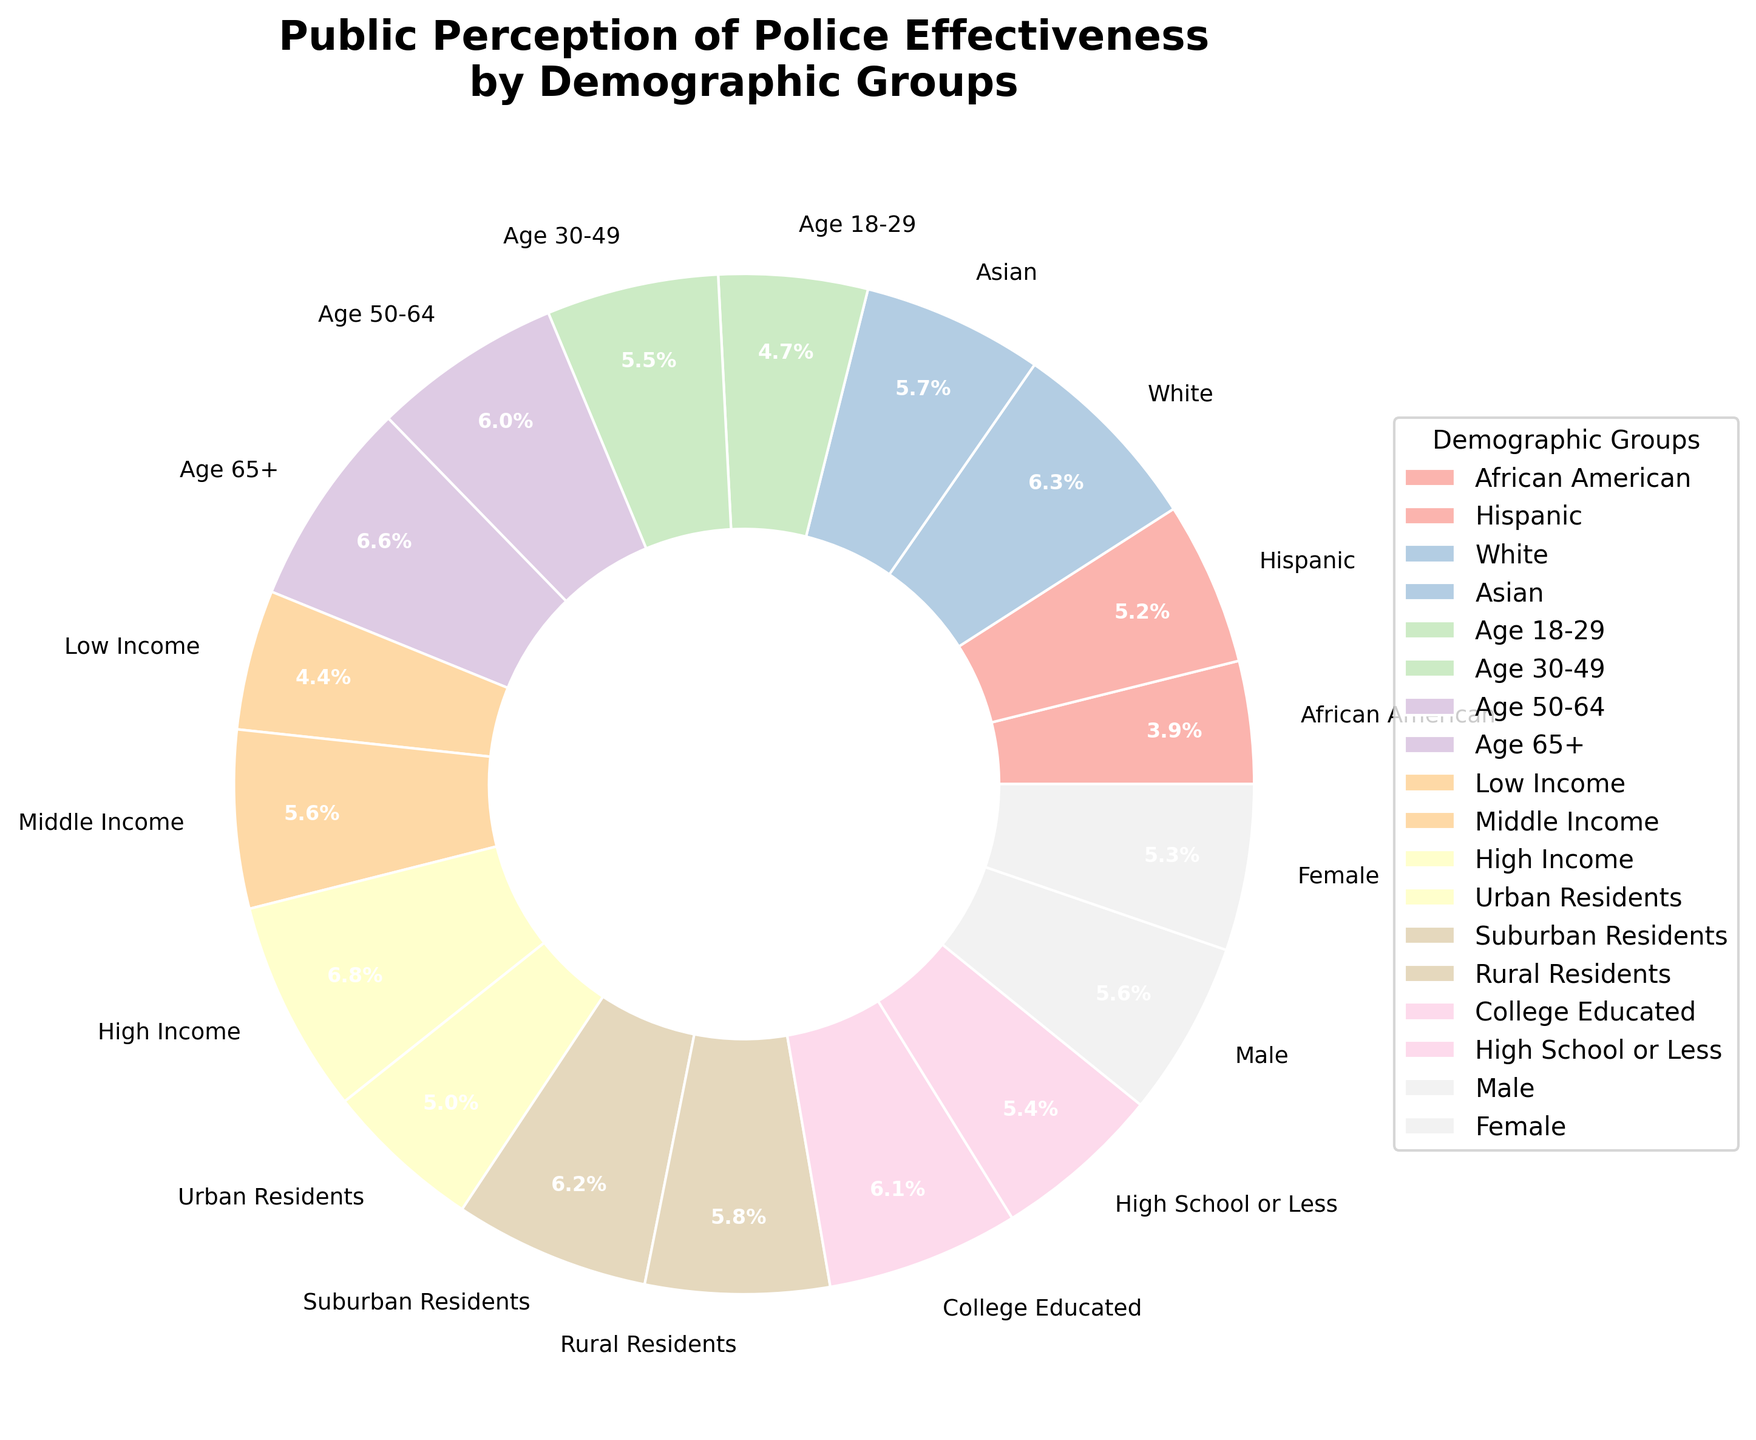Which demographic group has the highest positive perception of police effectiveness? The 'High Income' group has the highest positive perception percentage at 73%.
Answer: High Income Which demographic group has a higher positive perception percentage: African American or Asian? The Asian group has a higher positive perception percentage at 62%, compared to the African American group's 42%.
Answer: Asian What is the average positive perception percentage across Age groups? Sum the percentages of Age groups (51 + 59 + 65 + 71) and divide by the number of groups (4): (51 + 59 + 65 + 71) / 4 = 61.5.
Answer: 61.5 What is the total percentage of people in Urban and Suburban Residents combined? Add the percentages of Urban Residents and Suburban Residents: 54 + 67 = 121.
Answer: 121 By how many percentage points does Middle Income differ from Low Income in terms of positive perception? Subtract the percentage of Low Income from Middle Income: 61 - 48 = 13.
Answer: 13 How does the positive perception percentage of College Educated individuals compare to those with High School or Less? The College Educated group has a positive perception percentage of 66%, while High School or Less has 58%. College Educated is higher by 8 percentage points.
Answer: 8 What is the range of positive perception percentages among the Income groups? The highest percentage is in the High Income group (73%), and the lowest is in the Low Income group (48%). The range is 73 - 48 = 25.
Answer: 25 What is the median positive perception percentage among different Gender and Education groups combined? List the percentages of Male (60), Female (57), College Educated (66), and High School or Less (58). Arrange them in order: 57, 58, 60, 66. The median is the average of the two middle numbers: (58 + 60) / 2 = 59.
Answer: 59 Which Age group has the lowest positive perception percentage of police effectiveness? The 'Age 18-29' group has the lowest positive perception percentage at 51%.
Answer: Age 18-29 